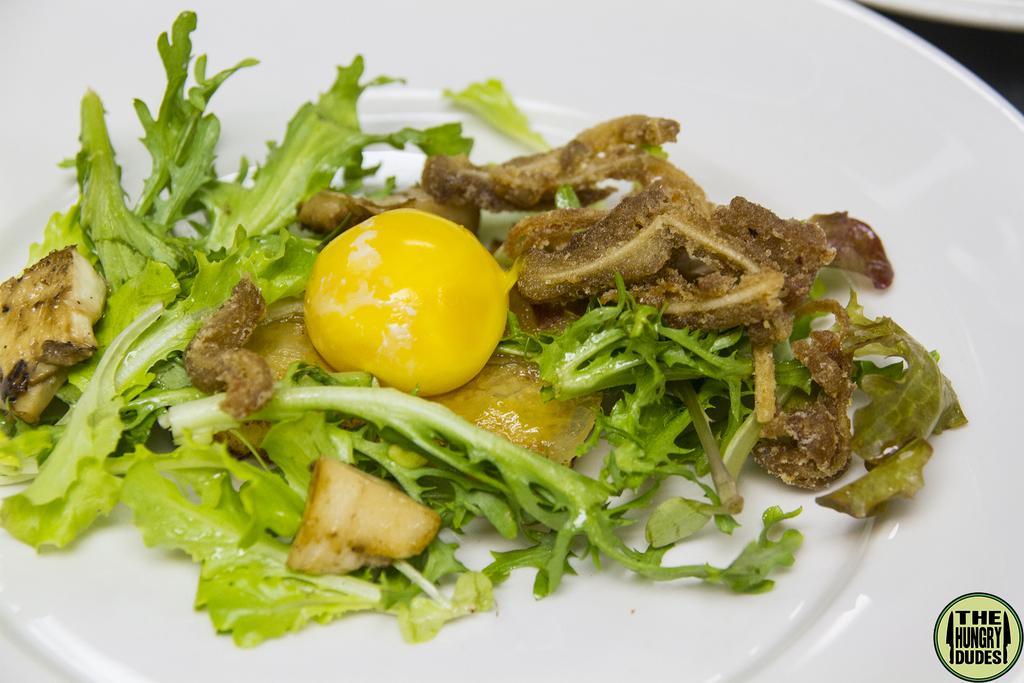In one or two sentences, can you explain what this image depicts? In the image we can see a plate, in the plate there is food. 